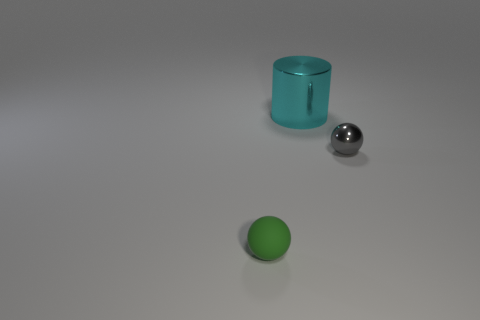Is there a tiny gray object that is on the right side of the large cyan shiny object on the left side of the small object that is to the right of the tiny green rubber sphere? Yes, the small, metallic, gray sphere is positioned to the right of the large, reflective cyan cylinder, itself located to the left of the small, shiny sphere, which in turn is placed to the right of the diminutive green rubber sphere on the surface. 